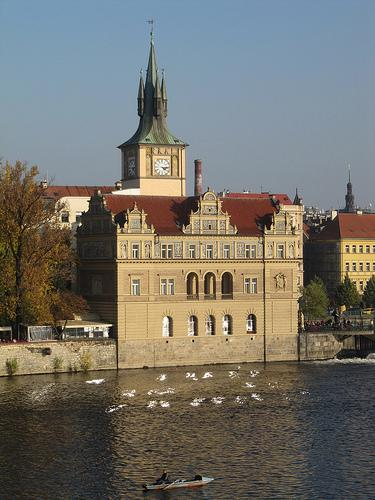Question: what time of day is it?
Choices:
A. Afternoon.
B. Evening.
C. Morning.
D. Night time.
Answer with the letter. Answer: C Question: what is the person in?
Choices:
A. A car.
B. A pool.
C. A boat.
D. A bathtub.
Answer with the letter. Answer: C Question: what color are the building roofs?
Choices:
A. Black.
B. White.
C. Red.
D. Blue.
Answer with the letter. Answer: C Question: what color is the sky?
Choices:
A. Gray.
B. Orange.
C. Blue.
D. Magenta.
Answer with the letter. Answer: C 